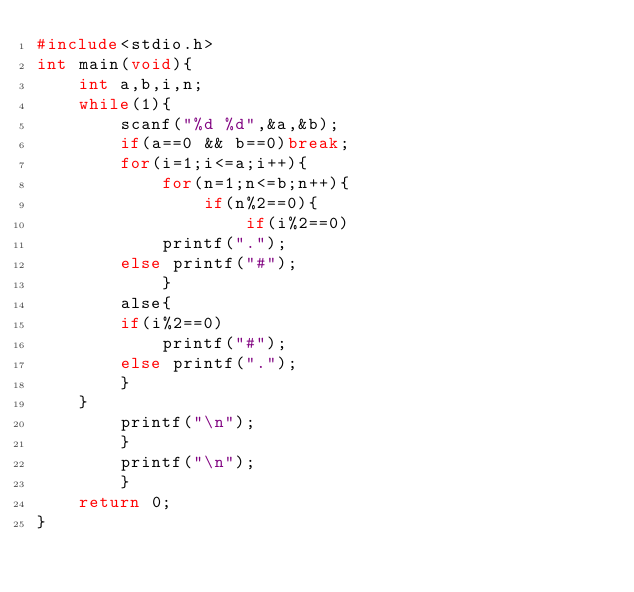Convert code to text. <code><loc_0><loc_0><loc_500><loc_500><_C_>#include<stdio.h>
int main(void){
    int a,b,i,n;
    while(1){
        scanf("%d %d",&a,&b);
        if(a==0 && b==0)break;
        for(i=1;i<=a;i++){
            for(n=1;n<=b;n++){
                if(n%2==0){
                    if(i%2==0)
            printf(".");
        else printf("#");
            }
        alse{
        if(i%2==0)
            printf("#");
        else printf(".");
        }
    }
        printf("\n");
        }
        printf("\n");
        }
    return 0;
}
</code> 